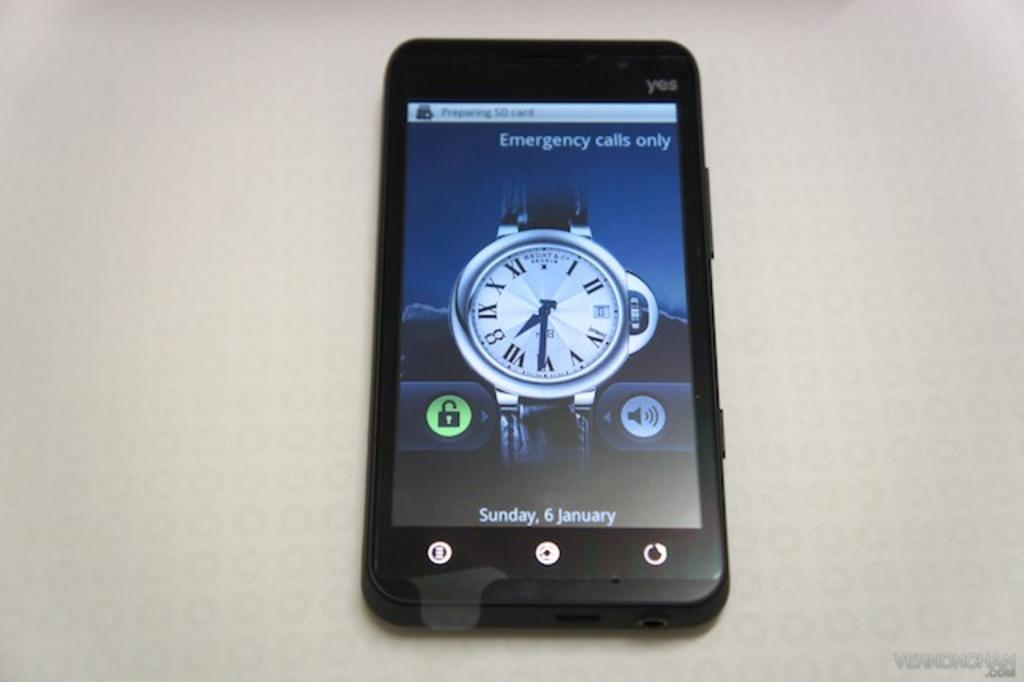Can you describe this image briefly? In this image we can see a mobile on the white surface. On the screen of the mobile we can see icons and a watch image. 